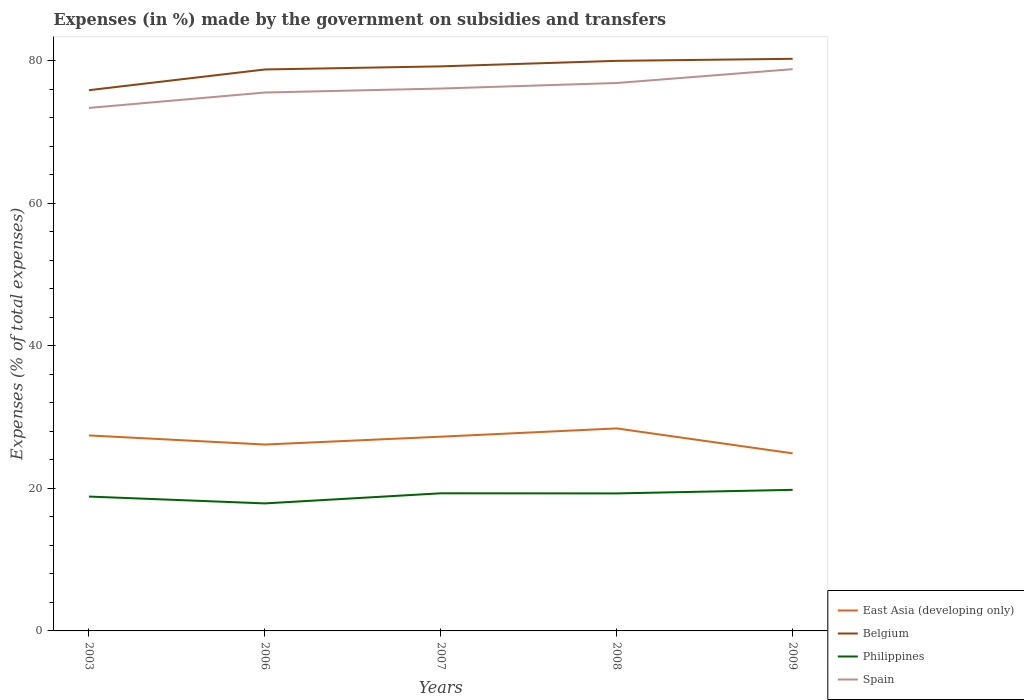How many different coloured lines are there?
Ensure brevity in your answer.  4. Does the line corresponding to Philippines intersect with the line corresponding to Spain?
Offer a very short reply. No. Across all years, what is the maximum percentage of expenses made by the government on subsidies and transfers in Belgium?
Ensure brevity in your answer.  75.85. In which year was the percentage of expenses made by the government on subsidies and transfers in East Asia (developing only) maximum?
Your response must be concise. 2009. What is the total percentage of expenses made by the government on subsidies and transfers in Spain in the graph?
Offer a very short reply. -1.94. What is the difference between the highest and the second highest percentage of expenses made by the government on subsidies and transfers in Spain?
Make the answer very short. 5.44. What is the difference between the highest and the lowest percentage of expenses made by the government on subsidies and transfers in East Asia (developing only)?
Keep it short and to the point. 3. Is the percentage of expenses made by the government on subsidies and transfers in Spain strictly greater than the percentage of expenses made by the government on subsidies and transfers in Philippines over the years?
Ensure brevity in your answer.  No. Are the values on the major ticks of Y-axis written in scientific E-notation?
Provide a short and direct response. No. Does the graph contain any zero values?
Give a very brief answer. No. Where does the legend appear in the graph?
Your answer should be compact. Bottom right. How many legend labels are there?
Offer a terse response. 4. How are the legend labels stacked?
Ensure brevity in your answer.  Vertical. What is the title of the graph?
Make the answer very short. Expenses (in %) made by the government on subsidies and transfers. Does "Venezuela" appear as one of the legend labels in the graph?
Give a very brief answer. No. What is the label or title of the X-axis?
Your response must be concise. Years. What is the label or title of the Y-axis?
Your response must be concise. Expenses (% of total expenses). What is the Expenses (% of total expenses) of East Asia (developing only) in 2003?
Provide a short and direct response. 27.42. What is the Expenses (% of total expenses) of Belgium in 2003?
Keep it short and to the point. 75.85. What is the Expenses (% of total expenses) of Philippines in 2003?
Your answer should be very brief. 18.85. What is the Expenses (% of total expenses) in Spain in 2003?
Give a very brief answer. 73.37. What is the Expenses (% of total expenses) in East Asia (developing only) in 2006?
Give a very brief answer. 26.15. What is the Expenses (% of total expenses) in Belgium in 2006?
Provide a succinct answer. 78.76. What is the Expenses (% of total expenses) of Philippines in 2006?
Ensure brevity in your answer.  17.89. What is the Expenses (% of total expenses) in Spain in 2006?
Your answer should be very brief. 75.53. What is the Expenses (% of total expenses) in East Asia (developing only) in 2007?
Ensure brevity in your answer.  27.25. What is the Expenses (% of total expenses) in Belgium in 2007?
Provide a succinct answer. 79.2. What is the Expenses (% of total expenses) of Philippines in 2007?
Your response must be concise. 19.31. What is the Expenses (% of total expenses) of Spain in 2007?
Ensure brevity in your answer.  76.09. What is the Expenses (% of total expenses) of East Asia (developing only) in 2008?
Provide a short and direct response. 28.41. What is the Expenses (% of total expenses) of Belgium in 2008?
Provide a short and direct response. 79.97. What is the Expenses (% of total expenses) in Philippines in 2008?
Make the answer very short. 19.29. What is the Expenses (% of total expenses) of Spain in 2008?
Keep it short and to the point. 76.86. What is the Expenses (% of total expenses) of East Asia (developing only) in 2009?
Your answer should be very brief. 24.91. What is the Expenses (% of total expenses) of Belgium in 2009?
Provide a succinct answer. 80.26. What is the Expenses (% of total expenses) in Philippines in 2009?
Your answer should be compact. 19.79. What is the Expenses (% of total expenses) in Spain in 2009?
Ensure brevity in your answer.  78.8. Across all years, what is the maximum Expenses (% of total expenses) of East Asia (developing only)?
Your answer should be very brief. 28.41. Across all years, what is the maximum Expenses (% of total expenses) in Belgium?
Your answer should be compact. 80.26. Across all years, what is the maximum Expenses (% of total expenses) in Philippines?
Make the answer very short. 19.79. Across all years, what is the maximum Expenses (% of total expenses) of Spain?
Your response must be concise. 78.8. Across all years, what is the minimum Expenses (% of total expenses) of East Asia (developing only)?
Your answer should be compact. 24.91. Across all years, what is the minimum Expenses (% of total expenses) of Belgium?
Your response must be concise. 75.85. Across all years, what is the minimum Expenses (% of total expenses) of Philippines?
Offer a terse response. 17.89. Across all years, what is the minimum Expenses (% of total expenses) of Spain?
Your answer should be very brief. 73.37. What is the total Expenses (% of total expenses) of East Asia (developing only) in the graph?
Provide a succinct answer. 134.14. What is the total Expenses (% of total expenses) of Belgium in the graph?
Keep it short and to the point. 394.04. What is the total Expenses (% of total expenses) in Philippines in the graph?
Offer a very short reply. 95.12. What is the total Expenses (% of total expenses) of Spain in the graph?
Keep it short and to the point. 380.64. What is the difference between the Expenses (% of total expenses) of East Asia (developing only) in 2003 and that in 2006?
Offer a very short reply. 1.28. What is the difference between the Expenses (% of total expenses) of Belgium in 2003 and that in 2006?
Make the answer very short. -2.91. What is the difference between the Expenses (% of total expenses) in Philippines in 2003 and that in 2006?
Offer a terse response. 0.96. What is the difference between the Expenses (% of total expenses) of Spain in 2003 and that in 2006?
Ensure brevity in your answer.  -2.16. What is the difference between the Expenses (% of total expenses) in East Asia (developing only) in 2003 and that in 2007?
Offer a terse response. 0.18. What is the difference between the Expenses (% of total expenses) in Belgium in 2003 and that in 2007?
Offer a terse response. -3.34. What is the difference between the Expenses (% of total expenses) of Philippines in 2003 and that in 2007?
Provide a succinct answer. -0.46. What is the difference between the Expenses (% of total expenses) of Spain in 2003 and that in 2007?
Ensure brevity in your answer.  -2.72. What is the difference between the Expenses (% of total expenses) of East Asia (developing only) in 2003 and that in 2008?
Make the answer very short. -0.98. What is the difference between the Expenses (% of total expenses) of Belgium in 2003 and that in 2008?
Offer a very short reply. -4.12. What is the difference between the Expenses (% of total expenses) in Philippines in 2003 and that in 2008?
Ensure brevity in your answer.  -0.44. What is the difference between the Expenses (% of total expenses) in Spain in 2003 and that in 2008?
Your answer should be very brief. -3.5. What is the difference between the Expenses (% of total expenses) of East Asia (developing only) in 2003 and that in 2009?
Your answer should be very brief. 2.52. What is the difference between the Expenses (% of total expenses) of Belgium in 2003 and that in 2009?
Offer a terse response. -4.4. What is the difference between the Expenses (% of total expenses) of Philippines in 2003 and that in 2009?
Offer a terse response. -0.94. What is the difference between the Expenses (% of total expenses) of Spain in 2003 and that in 2009?
Ensure brevity in your answer.  -5.44. What is the difference between the Expenses (% of total expenses) in East Asia (developing only) in 2006 and that in 2007?
Provide a succinct answer. -1.1. What is the difference between the Expenses (% of total expenses) in Belgium in 2006 and that in 2007?
Provide a short and direct response. -0.44. What is the difference between the Expenses (% of total expenses) in Philippines in 2006 and that in 2007?
Offer a terse response. -1.42. What is the difference between the Expenses (% of total expenses) of Spain in 2006 and that in 2007?
Offer a terse response. -0.56. What is the difference between the Expenses (% of total expenses) in East Asia (developing only) in 2006 and that in 2008?
Your response must be concise. -2.26. What is the difference between the Expenses (% of total expenses) in Belgium in 2006 and that in 2008?
Your response must be concise. -1.21. What is the difference between the Expenses (% of total expenses) in Philippines in 2006 and that in 2008?
Ensure brevity in your answer.  -1.4. What is the difference between the Expenses (% of total expenses) of Spain in 2006 and that in 2008?
Offer a very short reply. -1.33. What is the difference between the Expenses (% of total expenses) in East Asia (developing only) in 2006 and that in 2009?
Ensure brevity in your answer.  1.24. What is the difference between the Expenses (% of total expenses) of Belgium in 2006 and that in 2009?
Your answer should be very brief. -1.5. What is the difference between the Expenses (% of total expenses) of Philippines in 2006 and that in 2009?
Your answer should be compact. -1.9. What is the difference between the Expenses (% of total expenses) of Spain in 2006 and that in 2009?
Your answer should be compact. -3.28. What is the difference between the Expenses (% of total expenses) in East Asia (developing only) in 2007 and that in 2008?
Your answer should be very brief. -1.16. What is the difference between the Expenses (% of total expenses) of Belgium in 2007 and that in 2008?
Provide a short and direct response. -0.77. What is the difference between the Expenses (% of total expenses) of Philippines in 2007 and that in 2008?
Ensure brevity in your answer.  0.02. What is the difference between the Expenses (% of total expenses) in Spain in 2007 and that in 2008?
Offer a very short reply. -0.78. What is the difference between the Expenses (% of total expenses) in East Asia (developing only) in 2007 and that in 2009?
Offer a terse response. 2.34. What is the difference between the Expenses (% of total expenses) in Belgium in 2007 and that in 2009?
Keep it short and to the point. -1.06. What is the difference between the Expenses (% of total expenses) of Philippines in 2007 and that in 2009?
Provide a short and direct response. -0.49. What is the difference between the Expenses (% of total expenses) in Spain in 2007 and that in 2009?
Your response must be concise. -2.72. What is the difference between the Expenses (% of total expenses) in East Asia (developing only) in 2008 and that in 2009?
Your answer should be very brief. 3.5. What is the difference between the Expenses (% of total expenses) of Belgium in 2008 and that in 2009?
Your response must be concise. -0.29. What is the difference between the Expenses (% of total expenses) of Philippines in 2008 and that in 2009?
Offer a terse response. -0.5. What is the difference between the Expenses (% of total expenses) in Spain in 2008 and that in 2009?
Your response must be concise. -1.94. What is the difference between the Expenses (% of total expenses) in East Asia (developing only) in 2003 and the Expenses (% of total expenses) in Belgium in 2006?
Your answer should be very brief. -51.34. What is the difference between the Expenses (% of total expenses) in East Asia (developing only) in 2003 and the Expenses (% of total expenses) in Philippines in 2006?
Your answer should be very brief. 9.54. What is the difference between the Expenses (% of total expenses) of East Asia (developing only) in 2003 and the Expenses (% of total expenses) of Spain in 2006?
Keep it short and to the point. -48.1. What is the difference between the Expenses (% of total expenses) in Belgium in 2003 and the Expenses (% of total expenses) in Philippines in 2006?
Your response must be concise. 57.97. What is the difference between the Expenses (% of total expenses) in Belgium in 2003 and the Expenses (% of total expenses) in Spain in 2006?
Your answer should be compact. 0.33. What is the difference between the Expenses (% of total expenses) in Philippines in 2003 and the Expenses (% of total expenses) in Spain in 2006?
Offer a very short reply. -56.68. What is the difference between the Expenses (% of total expenses) of East Asia (developing only) in 2003 and the Expenses (% of total expenses) of Belgium in 2007?
Offer a terse response. -51.77. What is the difference between the Expenses (% of total expenses) of East Asia (developing only) in 2003 and the Expenses (% of total expenses) of Philippines in 2007?
Ensure brevity in your answer.  8.12. What is the difference between the Expenses (% of total expenses) of East Asia (developing only) in 2003 and the Expenses (% of total expenses) of Spain in 2007?
Your response must be concise. -48.66. What is the difference between the Expenses (% of total expenses) of Belgium in 2003 and the Expenses (% of total expenses) of Philippines in 2007?
Give a very brief answer. 56.55. What is the difference between the Expenses (% of total expenses) in Belgium in 2003 and the Expenses (% of total expenses) in Spain in 2007?
Give a very brief answer. -0.23. What is the difference between the Expenses (% of total expenses) of Philippines in 2003 and the Expenses (% of total expenses) of Spain in 2007?
Give a very brief answer. -57.24. What is the difference between the Expenses (% of total expenses) of East Asia (developing only) in 2003 and the Expenses (% of total expenses) of Belgium in 2008?
Keep it short and to the point. -52.55. What is the difference between the Expenses (% of total expenses) of East Asia (developing only) in 2003 and the Expenses (% of total expenses) of Philippines in 2008?
Your answer should be very brief. 8.14. What is the difference between the Expenses (% of total expenses) of East Asia (developing only) in 2003 and the Expenses (% of total expenses) of Spain in 2008?
Your response must be concise. -49.44. What is the difference between the Expenses (% of total expenses) in Belgium in 2003 and the Expenses (% of total expenses) in Philippines in 2008?
Give a very brief answer. 56.57. What is the difference between the Expenses (% of total expenses) in Belgium in 2003 and the Expenses (% of total expenses) in Spain in 2008?
Offer a very short reply. -1.01. What is the difference between the Expenses (% of total expenses) of Philippines in 2003 and the Expenses (% of total expenses) of Spain in 2008?
Ensure brevity in your answer.  -58.01. What is the difference between the Expenses (% of total expenses) in East Asia (developing only) in 2003 and the Expenses (% of total expenses) in Belgium in 2009?
Your answer should be compact. -52.83. What is the difference between the Expenses (% of total expenses) in East Asia (developing only) in 2003 and the Expenses (% of total expenses) in Philippines in 2009?
Offer a terse response. 7.63. What is the difference between the Expenses (% of total expenses) in East Asia (developing only) in 2003 and the Expenses (% of total expenses) in Spain in 2009?
Your answer should be very brief. -51.38. What is the difference between the Expenses (% of total expenses) of Belgium in 2003 and the Expenses (% of total expenses) of Philippines in 2009?
Your answer should be very brief. 56.06. What is the difference between the Expenses (% of total expenses) of Belgium in 2003 and the Expenses (% of total expenses) of Spain in 2009?
Provide a short and direct response. -2.95. What is the difference between the Expenses (% of total expenses) in Philippines in 2003 and the Expenses (% of total expenses) in Spain in 2009?
Provide a short and direct response. -59.95. What is the difference between the Expenses (% of total expenses) of East Asia (developing only) in 2006 and the Expenses (% of total expenses) of Belgium in 2007?
Give a very brief answer. -53.05. What is the difference between the Expenses (% of total expenses) in East Asia (developing only) in 2006 and the Expenses (% of total expenses) in Philippines in 2007?
Offer a terse response. 6.84. What is the difference between the Expenses (% of total expenses) of East Asia (developing only) in 2006 and the Expenses (% of total expenses) of Spain in 2007?
Your answer should be compact. -49.94. What is the difference between the Expenses (% of total expenses) in Belgium in 2006 and the Expenses (% of total expenses) in Philippines in 2007?
Offer a very short reply. 59.45. What is the difference between the Expenses (% of total expenses) of Belgium in 2006 and the Expenses (% of total expenses) of Spain in 2007?
Make the answer very short. 2.67. What is the difference between the Expenses (% of total expenses) of Philippines in 2006 and the Expenses (% of total expenses) of Spain in 2007?
Make the answer very short. -58.2. What is the difference between the Expenses (% of total expenses) in East Asia (developing only) in 2006 and the Expenses (% of total expenses) in Belgium in 2008?
Offer a terse response. -53.82. What is the difference between the Expenses (% of total expenses) in East Asia (developing only) in 2006 and the Expenses (% of total expenses) in Philippines in 2008?
Offer a terse response. 6.86. What is the difference between the Expenses (% of total expenses) in East Asia (developing only) in 2006 and the Expenses (% of total expenses) in Spain in 2008?
Ensure brevity in your answer.  -50.71. What is the difference between the Expenses (% of total expenses) in Belgium in 2006 and the Expenses (% of total expenses) in Philippines in 2008?
Give a very brief answer. 59.47. What is the difference between the Expenses (% of total expenses) in Belgium in 2006 and the Expenses (% of total expenses) in Spain in 2008?
Keep it short and to the point. 1.9. What is the difference between the Expenses (% of total expenses) in Philippines in 2006 and the Expenses (% of total expenses) in Spain in 2008?
Provide a short and direct response. -58.97. What is the difference between the Expenses (% of total expenses) of East Asia (developing only) in 2006 and the Expenses (% of total expenses) of Belgium in 2009?
Provide a short and direct response. -54.11. What is the difference between the Expenses (% of total expenses) in East Asia (developing only) in 2006 and the Expenses (% of total expenses) in Philippines in 2009?
Your response must be concise. 6.36. What is the difference between the Expenses (% of total expenses) of East Asia (developing only) in 2006 and the Expenses (% of total expenses) of Spain in 2009?
Offer a terse response. -52.66. What is the difference between the Expenses (% of total expenses) in Belgium in 2006 and the Expenses (% of total expenses) in Philippines in 2009?
Your answer should be very brief. 58.97. What is the difference between the Expenses (% of total expenses) of Belgium in 2006 and the Expenses (% of total expenses) of Spain in 2009?
Ensure brevity in your answer.  -0.04. What is the difference between the Expenses (% of total expenses) of Philippines in 2006 and the Expenses (% of total expenses) of Spain in 2009?
Provide a succinct answer. -60.91. What is the difference between the Expenses (% of total expenses) in East Asia (developing only) in 2007 and the Expenses (% of total expenses) in Belgium in 2008?
Provide a succinct answer. -52.72. What is the difference between the Expenses (% of total expenses) of East Asia (developing only) in 2007 and the Expenses (% of total expenses) of Philippines in 2008?
Offer a very short reply. 7.96. What is the difference between the Expenses (% of total expenses) of East Asia (developing only) in 2007 and the Expenses (% of total expenses) of Spain in 2008?
Provide a short and direct response. -49.61. What is the difference between the Expenses (% of total expenses) in Belgium in 2007 and the Expenses (% of total expenses) in Philippines in 2008?
Provide a short and direct response. 59.91. What is the difference between the Expenses (% of total expenses) of Belgium in 2007 and the Expenses (% of total expenses) of Spain in 2008?
Offer a terse response. 2.33. What is the difference between the Expenses (% of total expenses) in Philippines in 2007 and the Expenses (% of total expenses) in Spain in 2008?
Offer a very short reply. -57.56. What is the difference between the Expenses (% of total expenses) of East Asia (developing only) in 2007 and the Expenses (% of total expenses) of Belgium in 2009?
Provide a short and direct response. -53.01. What is the difference between the Expenses (% of total expenses) of East Asia (developing only) in 2007 and the Expenses (% of total expenses) of Philippines in 2009?
Offer a very short reply. 7.46. What is the difference between the Expenses (% of total expenses) in East Asia (developing only) in 2007 and the Expenses (% of total expenses) in Spain in 2009?
Your answer should be compact. -51.55. What is the difference between the Expenses (% of total expenses) of Belgium in 2007 and the Expenses (% of total expenses) of Philippines in 2009?
Ensure brevity in your answer.  59.41. What is the difference between the Expenses (% of total expenses) in Belgium in 2007 and the Expenses (% of total expenses) in Spain in 2009?
Your answer should be very brief. 0.39. What is the difference between the Expenses (% of total expenses) of Philippines in 2007 and the Expenses (% of total expenses) of Spain in 2009?
Your response must be concise. -59.5. What is the difference between the Expenses (% of total expenses) of East Asia (developing only) in 2008 and the Expenses (% of total expenses) of Belgium in 2009?
Provide a short and direct response. -51.85. What is the difference between the Expenses (% of total expenses) in East Asia (developing only) in 2008 and the Expenses (% of total expenses) in Philippines in 2009?
Provide a succinct answer. 8.62. What is the difference between the Expenses (% of total expenses) of East Asia (developing only) in 2008 and the Expenses (% of total expenses) of Spain in 2009?
Offer a terse response. -50.39. What is the difference between the Expenses (% of total expenses) in Belgium in 2008 and the Expenses (% of total expenses) in Philippines in 2009?
Offer a very short reply. 60.18. What is the difference between the Expenses (% of total expenses) in Belgium in 2008 and the Expenses (% of total expenses) in Spain in 2009?
Your answer should be compact. 1.17. What is the difference between the Expenses (% of total expenses) in Philippines in 2008 and the Expenses (% of total expenses) in Spain in 2009?
Keep it short and to the point. -59.51. What is the average Expenses (% of total expenses) of East Asia (developing only) per year?
Give a very brief answer. 26.83. What is the average Expenses (% of total expenses) of Belgium per year?
Provide a short and direct response. 78.81. What is the average Expenses (% of total expenses) of Philippines per year?
Provide a succinct answer. 19.02. What is the average Expenses (% of total expenses) in Spain per year?
Ensure brevity in your answer.  76.13. In the year 2003, what is the difference between the Expenses (% of total expenses) in East Asia (developing only) and Expenses (% of total expenses) in Belgium?
Offer a terse response. -48.43. In the year 2003, what is the difference between the Expenses (% of total expenses) of East Asia (developing only) and Expenses (% of total expenses) of Philippines?
Your answer should be very brief. 8.58. In the year 2003, what is the difference between the Expenses (% of total expenses) in East Asia (developing only) and Expenses (% of total expenses) in Spain?
Ensure brevity in your answer.  -45.94. In the year 2003, what is the difference between the Expenses (% of total expenses) of Belgium and Expenses (% of total expenses) of Philippines?
Provide a succinct answer. 57. In the year 2003, what is the difference between the Expenses (% of total expenses) of Belgium and Expenses (% of total expenses) of Spain?
Make the answer very short. 2.49. In the year 2003, what is the difference between the Expenses (% of total expenses) of Philippines and Expenses (% of total expenses) of Spain?
Provide a short and direct response. -54.52. In the year 2006, what is the difference between the Expenses (% of total expenses) of East Asia (developing only) and Expenses (% of total expenses) of Belgium?
Offer a very short reply. -52.61. In the year 2006, what is the difference between the Expenses (% of total expenses) of East Asia (developing only) and Expenses (% of total expenses) of Philippines?
Keep it short and to the point. 8.26. In the year 2006, what is the difference between the Expenses (% of total expenses) of East Asia (developing only) and Expenses (% of total expenses) of Spain?
Give a very brief answer. -49.38. In the year 2006, what is the difference between the Expenses (% of total expenses) of Belgium and Expenses (% of total expenses) of Philippines?
Ensure brevity in your answer.  60.87. In the year 2006, what is the difference between the Expenses (% of total expenses) in Belgium and Expenses (% of total expenses) in Spain?
Keep it short and to the point. 3.23. In the year 2006, what is the difference between the Expenses (% of total expenses) of Philippines and Expenses (% of total expenses) of Spain?
Keep it short and to the point. -57.64. In the year 2007, what is the difference between the Expenses (% of total expenses) in East Asia (developing only) and Expenses (% of total expenses) in Belgium?
Offer a very short reply. -51.95. In the year 2007, what is the difference between the Expenses (% of total expenses) in East Asia (developing only) and Expenses (% of total expenses) in Philippines?
Provide a short and direct response. 7.94. In the year 2007, what is the difference between the Expenses (% of total expenses) of East Asia (developing only) and Expenses (% of total expenses) of Spain?
Offer a very short reply. -48.84. In the year 2007, what is the difference between the Expenses (% of total expenses) of Belgium and Expenses (% of total expenses) of Philippines?
Give a very brief answer. 59.89. In the year 2007, what is the difference between the Expenses (% of total expenses) of Belgium and Expenses (% of total expenses) of Spain?
Your answer should be very brief. 3.11. In the year 2007, what is the difference between the Expenses (% of total expenses) in Philippines and Expenses (% of total expenses) in Spain?
Offer a terse response. -56.78. In the year 2008, what is the difference between the Expenses (% of total expenses) of East Asia (developing only) and Expenses (% of total expenses) of Belgium?
Keep it short and to the point. -51.56. In the year 2008, what is the difference between the Expenses (% of total expenses) in East Asia (developing only) and Expenses (% of total expenses) in Philippines?
Keep it short and to the point. 9.12. In the year 2008, what is the difference between the Expenses (% of total expenses) of East Asia (developing only) and Expenses (% of total expenses) of Spain?
Offer a very short reply. -48.45. In the year 2008, what is the difference between the Expenses (% of total expenses) of Belgium and Expenses (% of total expenses) of Philippines?
Make the answer very short. 60.68. In the year 2008, what is the difference between the Expenses (% of total expenses) of Belgium and Expenses (% of total expenses) of Spain?
Your answer should be compact. 3.11. In the year 2008, what is the difference between the Expenses (% of total expenses) in Philippines and Expenses (% of total expenses) in Spain?
Provide a succinct answer. -57.57. In the year 2009, what is the difference between the Expenses (% of total expenses) in East Asia (developing only) and Expenses (% of total expenses) in Belgium?
Offer a terse response. -55.35. In the year 2009, what is the difference between the Expenses (% of total expenses) in East Asia (developing only) and Expenses (% of total expenses) in Philippines?
Your response must be concise. 5.12. In the year 2009, what is the difference between the Expenses (% of total expenses) in East Asia (developing only) and Expenses (% of total expenses) in Spain?
Your answer should be compact. -53.89. In the year 2009, what is the difference between the Expenses (% of total expenses) of Belgium and Expenses (% of total expenses) of Philippines?
Offer a very short reply. 60.47. In the year 2009, what is the difference between the Expenses (% of total expenses) in Belgium and Expenses (% of total expenses) in Spain?
Keep it short and to the point. 1.45. In the year 2009, what is the difference between the Expenses (% of total expenses) in Philippines and Expenses (% of total expenses) in Spain?
Your answer should be compact. -59.01. What is the ratio of the Expenses (% of total expenses) of East Asia (developing only) in 2003 to that in 2006?
Your answer should be compact. 1.05. What is the ratio of the Expenses (% of total expenses) in Belgium in 2003 to that in 2006?
Your answer should be very brief. 0.96. What is the ratio of the Expenses (% of total expenses) in Philippines in 2003 to that in 2006?
Your answer should be compact. 1.05. What is the ratio of the Expenses (% of total expenses) of Spain in 2003 to that in 2006?
Offer a terse response. 0.97. What is the ratio of the Expenses (% of total expenses) in Belgium in 2003 to that in 2007?
Offer a terse response. 0.96. What is the ratio of the Expenses (% of total expenses) in Philippines in 2003 to that in 2007?
Offer a terse response. 0.98. What is the ratio of the Expenses (% of total expenses) of Spain in 2003 to that in 2007?
Your response must be concise. 0.96. What is the ratio of the Expenses (% of total expenses) of East Asia (developing only) in 2003 to that in 2008?
Offer a terse response. 0.97. What is the ratio of the Expenses (% of total expenses) in Belgium in 2003 to that in 2008?
Your answer should be very brief. 0.95. What is the ratio of the Expenses (% of total expenses) of Philippines in 2003 to that in 2008?
Your response must be concise. 0.98. What is the ratio of the Expenses (% of total expenses) of Spain in 2003 to that in 2008?
Provide a short and direct response. 0.95. What is the ratio of the Expenses (% of total expenses) in East Asia (developing only) in 2003 to that in 2009?
Your response must be concise. 1.1. What is the ratio of the Expenses (% of total expenses) in Belgium in 2003 to that in 2009?
Provide a short and direct response. 0.95. What is the ratio of the Expenses (% of total expenses) of Spain in 2003 to that in 2009?
Make the answer very short. 0.93. What is the ratio of the Expenses (% of total expenses) of East Asia (developing only) in 2006 to that in 2007?
Your response must be concise. 0.96. What is the ratio of the Expenses (% of total expenses) in Philippines in 2006 to that in 2007?
Provide a short and direct response. 0.93. What is the ratio of the Expenses (% of total expenses) in Spain in 2006 to that in 2007?
Provide a short and direct response. 0.99. What is the ratio of the Expenses (% of total expenses) in East Asia (developing only) in 2006 to that in 2008?
Ensure brevity in your answer.  0.92. What is the ratio of the Expenses (% of total expenses) of Belgium in 2006 to that in 2008?
Offer a terse response. 0.98. What is the ratio of the Expenses (% of total expenses) in Philippines in 2006 to that in 2008?
Your answer should be very brief. 0.93. What is the ratio of the Expenses (% of total expenses) in Spain in 2006 to that in 2008?
Provide a short and direct response. 0.98. What is the ratio of the Expenses (% of total expenses) in East Asia (developing only) in 2006 to that in 2009?
Provide a short and direct response. 1.05. What is the ratio of the Expenses (% of total expenses) of Belgium in 2006 to that in 2009?
Provide a succinct answer. 0.98. What is the ratio of the Expenses (% of total expenses) in Philippines in 2006 to that in 2009?
Ensure brevity in your answer.  0.9. What is the ratio of the Expenses (% of total expenses) of Spain in 2006 to that in 2009?
Your response must be concise. 0.96. What is the ratio of the Expenses (% of total expenses) of East Asia (developing only) in 2007 to that in 2008?
Your answer should be compact. 0.96. What is the ratio of the Expenses (% of total expenses) in Belgium in 2007 to that in 2008?
Ensure brevity in your answer.  0.99. What is the ratio of the Expenses (% of total expenses) of Spain in 2007 to that in 2008?
Provide a succinct answer. 0.99. What is the ratio of the Expenses (% of total expenses) in East Asia (developing only) in 2007 to that in 2009?
Provide a succinct answer. 1.09. What is the ratio of the Expenses (% of total expenses) of Belgium in 2007 to that in 2009?
Your answer should be very brief. 0.99. What is the ratio of the Expenses (% of total expenses) in Philippines in 2007 to that in 2009?
Keep it short and to the point. 0.98. What is the ratio of the Expenses (% of total expenses) of Spain in 2007 to that in 2009?
Ensure brevity in your answer.  0.97. What is the ratio of the Expenses (% of total expenses) in East Asia (developing only) in 2008 to that in 2009?
Provide a short and direct response. 1.14. What is the ratio of the Expenses (% of total expenses) of Belgium in 2008 to that in 2009?
Ensure brevity in your answer.  1. What is the ratio of the Expenses (% of total expenses) of Philippines in 2008 to that in 2009?
Make the answer very short. 0.97. What is the ratio of the Expenses (% of total expenses) of Spain in 2008 to that in 2009?
Your response must be concise. 0.98. What is the difference between the highest and the second highest Expenses (% of total expenses) in East Asia (developing only)?
Give a very brief answer. 0.98. What is the difference between the highest and the second highest Expenses (% of total expenses) of Belgium?
Ensure brevity in your answer.  0.29. What is the difference between the highest and the second highest Expenses (% of total expenses) of Philippines?
Your answer should be compact. 0.49. What is the difference between the highest and the second highest Expenses (% of total expenses) in Spain?
Your answer should be very brief. 1.94. What is the difference between the highest and the lowest Expenses (% of total expenses) in East Asia (developing only)?
Provide a short and direct response. 3.5. What is the difference between the highest and the lowest Expenses (% of total expenses) in Belgium?
Make the answer very short. 4.4. What is the difference between the highest and the lowest Expenses (% of total expenses) in Philippines?
Make the answer very short. 1.9. What is the difference between the highest and the lowest Expenses (% of total expenses) of Spain?
Provide a succinct answer. 5.44. 